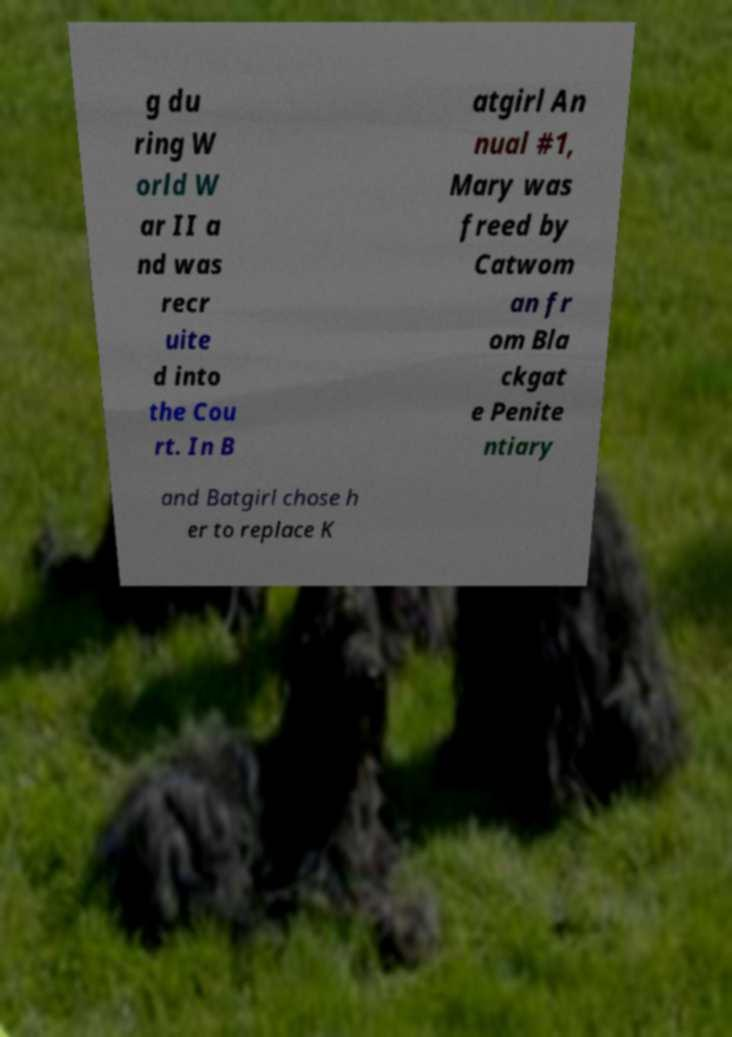Please identify and transcribe the text found in this image. g du ring W orld W ar II a nd was recr uite d into the Cou rt. In B atgirl An nual #1, Mary was freed by Catwom an fr om Bla ckgat e Penite ntiary and Batgirl chose h er to replace K 